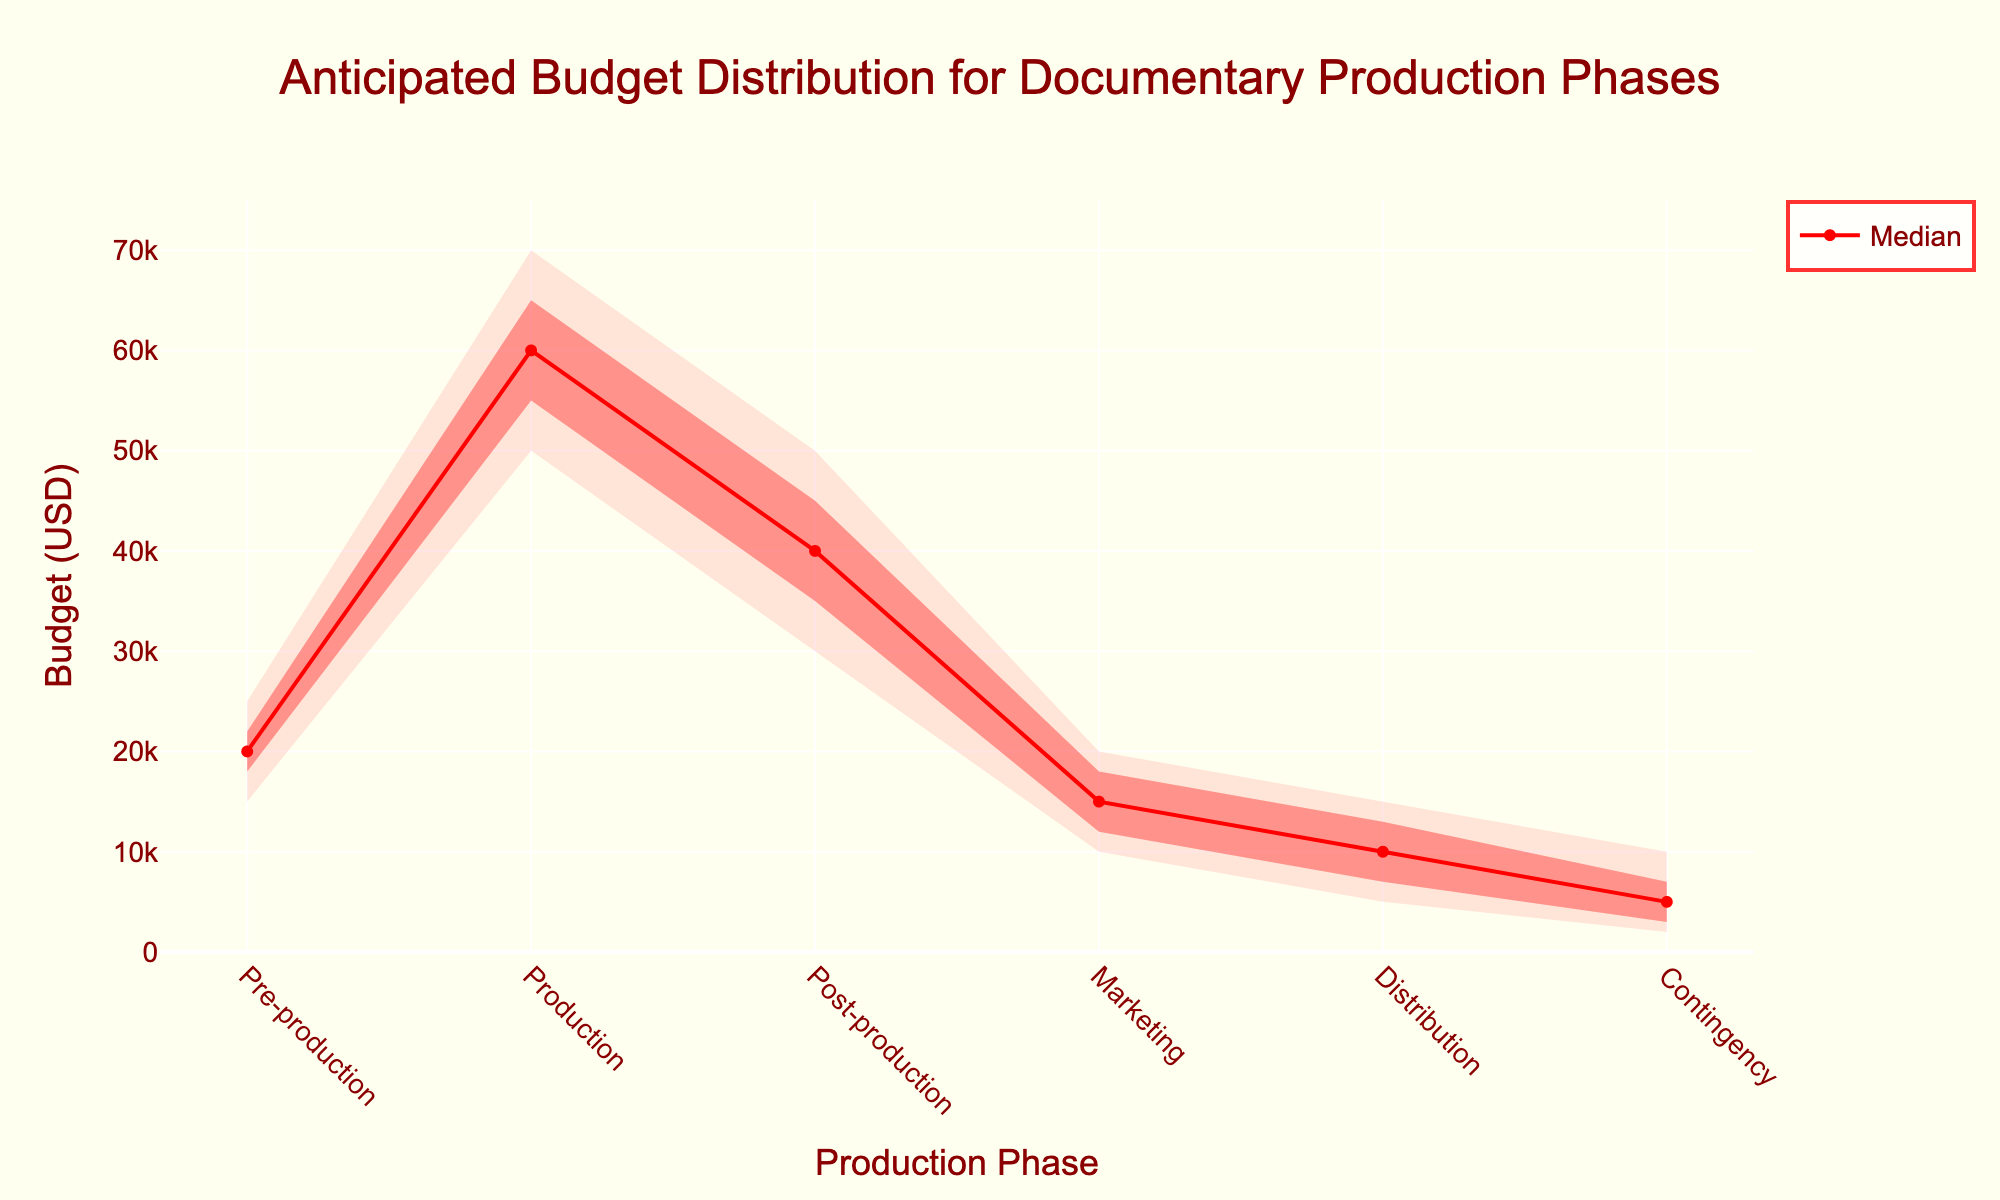What is the title of the fan chart? The title is located at the top center of the chart, displayed prominently in a large font size. It reads: "Anticipated Budget Distribution for Documentary Production Phases."
Answer: "Anticipated Budget Distribution for Documentary Production Phases" How much is the median budget for the Production phase? The median value for a phase can be found along the red median line. For the Production phase, the median budget is shown at the intersection of the median line and the Production phase, which is $60,000.
Answer: $60,000 Which phase has the widest budget range at the 25%-75% percentile level? To find this, compare the width of the shaded area between the 25% and 75% percentiles for each phase. The widest range is for the Production phase since it spans from $55,000 to $65,000, a difference of $10,000.
Answer: Production What is the budget range for the Marketing phase at the 10%-90% percentiles? The 10%-90% range can be found by observing the uppermost and lowermost shaded areas around each phase. For Marketing, the budget ranges from $10,000 at 10% to $20,000 at 90%.
Answer: $10,000 - $20,000 How does the median budget for Post-production compare to that of Pre-production? Find the median values for both phases along the red median line. Post-production has a median budget of $40,000, while Pre-production has a median budget of $20,000. Post-production's median budget is $20,000 higher.
Answer: $20,000 higher Which phase requires the least amount of budget at the 50% percentile? Looking at the median values (the red line) for each phase, the lowest is for the Distribution phase, which is $10,000.
Answer: Distribution What is the approximate difference between the 75th and 25th percentile budgets for the Post-production phase? For Post-production, identify the 75% budget ($45,000) and the 25% budget ($35,000). The difference is $45,000 - $35,000 = $10,000.
Answer: $10,000 Which phase's budget shows the most consistency (smallest range between 10% to 90% percentiles)? Consistency can be determined by the smallest range between the 10% and 90% percentiles. The Contingency phase shows the smallest range from $2,000 to $10,000, a difference of $8,000.
Answer: Contingency 